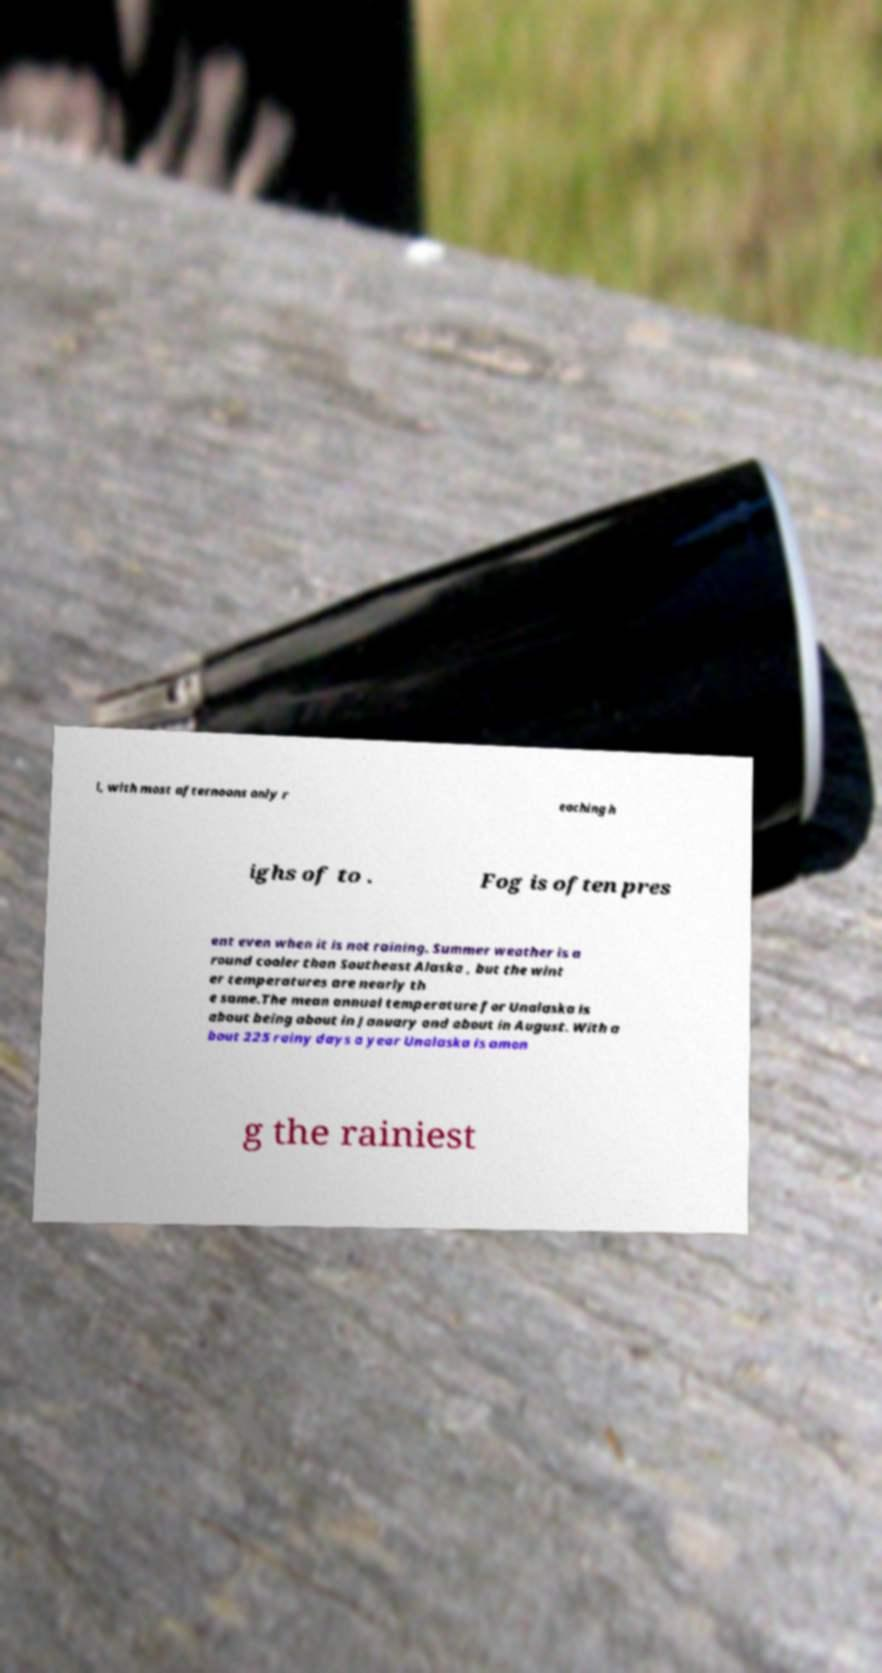There's text embedded in this image that I need extracted. Can you transcribe it verbatim? l, with most afternoons only r eaching h ighs of to . Fog is often pres ent even when it is not raining. Summer weather is a round cooler than Southeast Alaska , but the wint er temperatures are nearly th e same.The mean annual temperature for Unalaska is about being about in January and about in August. With a bout 225 rainy days a year Unalaska is amon g the rainiest 